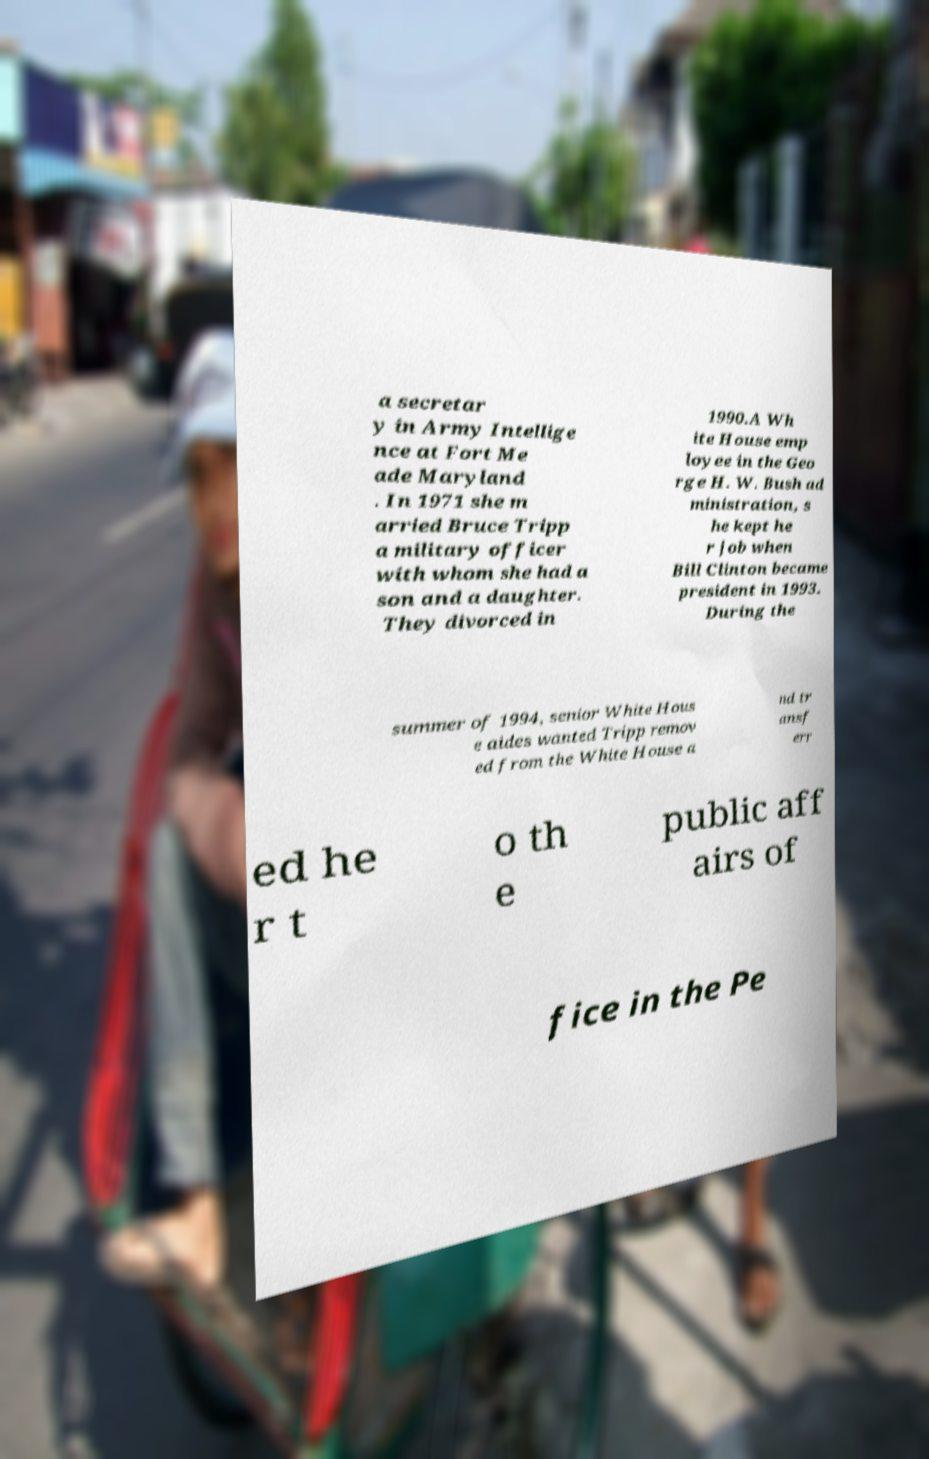Could you assist in decoding the text presented in this image and type it out clearly? a secretar y in Army Intellige nce at Fort Me ade Maryland . In 1971 she m arried Bruce Tripp a military officer with whom she had a son and a daughter. They divorced in 1990.A Wh ite House emp loyee in the Geo rge H. W. Bush ad ministration, s he kept he r job when Bill Clinton became president in 1993. During the summer of 1994, senior White Hous e aides wanted Tripp remov ed from the White House a nd tr ansf err ed he r t o th e public aff airs of fice in the Pe 